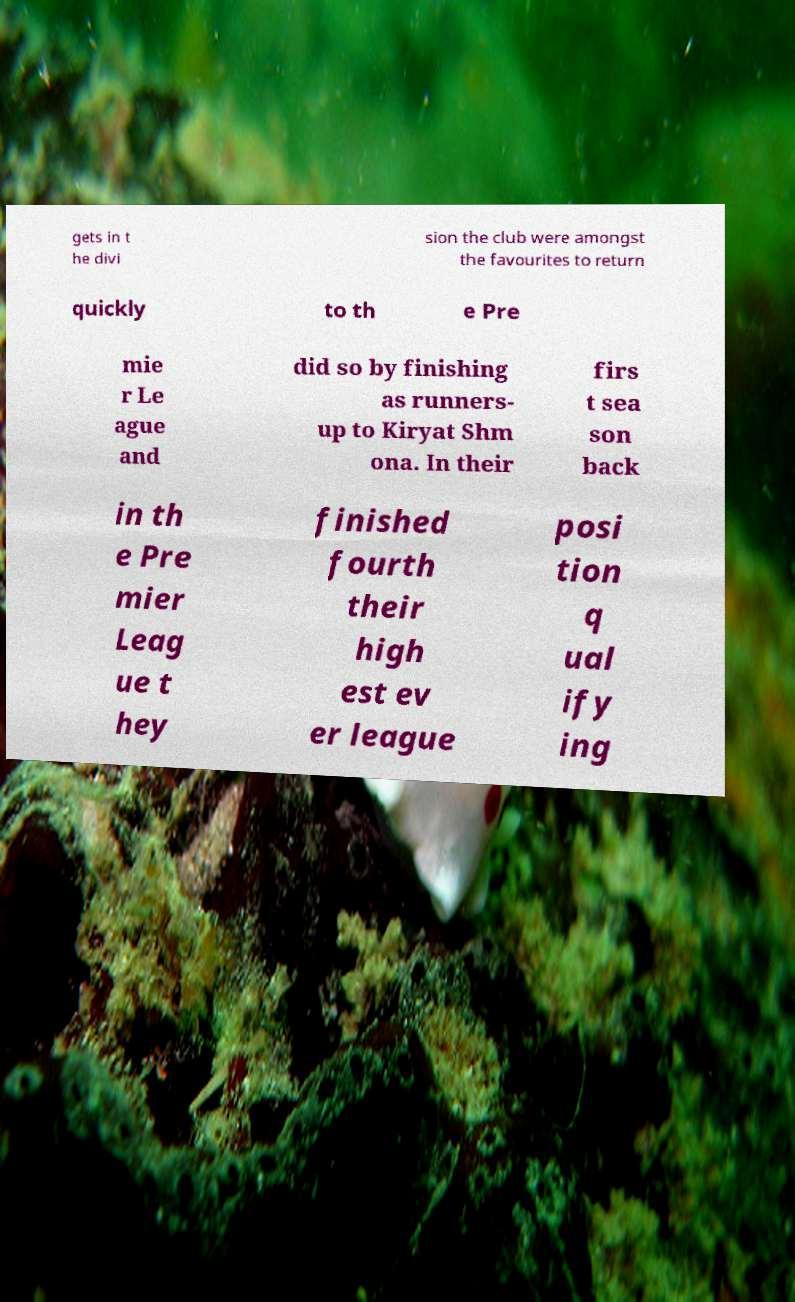Could you extract and type out the text from this image? gets in t he divi sion the club were amongst the favourites to return quickly to th e Pre mie r Le ague and did so by finishing as runners- up to Kiryat Shm ona. In their firs t sea son back in th e Pre mier Leag ue t hey finished fourth their high est ev er league posi tion q ual ify ing 